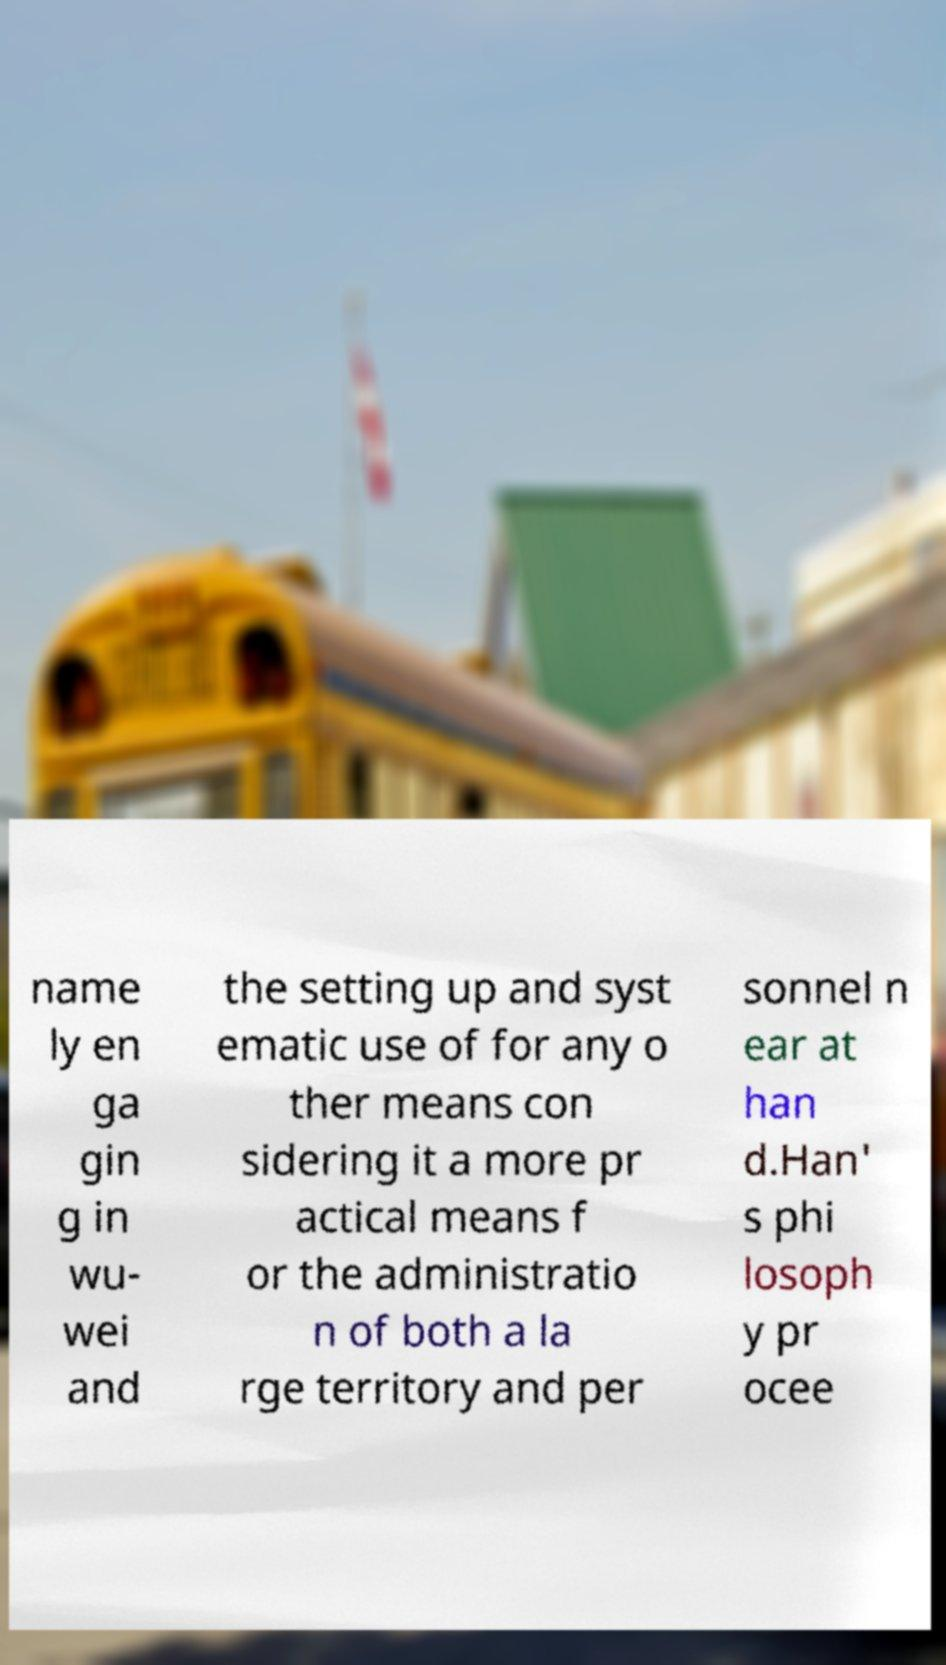Can you read and provide the text displayed in the image?This photo seems to have some interesting text. Can you extract and type it out for me? name ly en ga gin g in wu- wei and the setting up and syst ematic use of for any o ther means con sidering it a more pr actical means f or the administratio n of both a la rge territory and per sonnel n ear at han d.Han' s phi losoph y pr ocee 